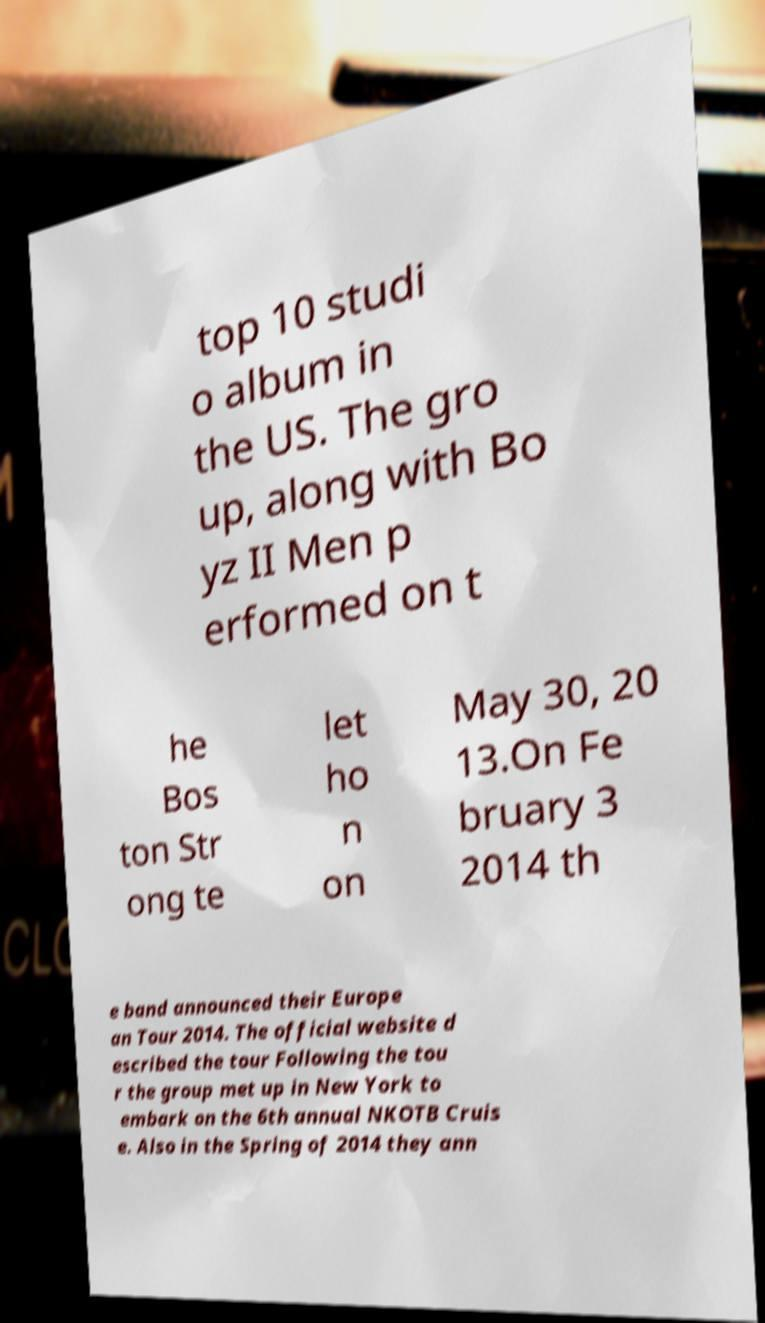Please identify and transcribe the text found in this image. top 10 studi o album in the US. The gro up, along with Bo yz II Men p erformed on t he Bos ton Str ong te let ho n on May 30, 20 13.On Fe bruary 3 2014 th e band announced their Europe an Tour 2014. The official website d escribed the tour Following the tou r the group met up in New York to embark on the 6th annual NKOTB Cruis e. Also in the Spring of 2014 they ann 